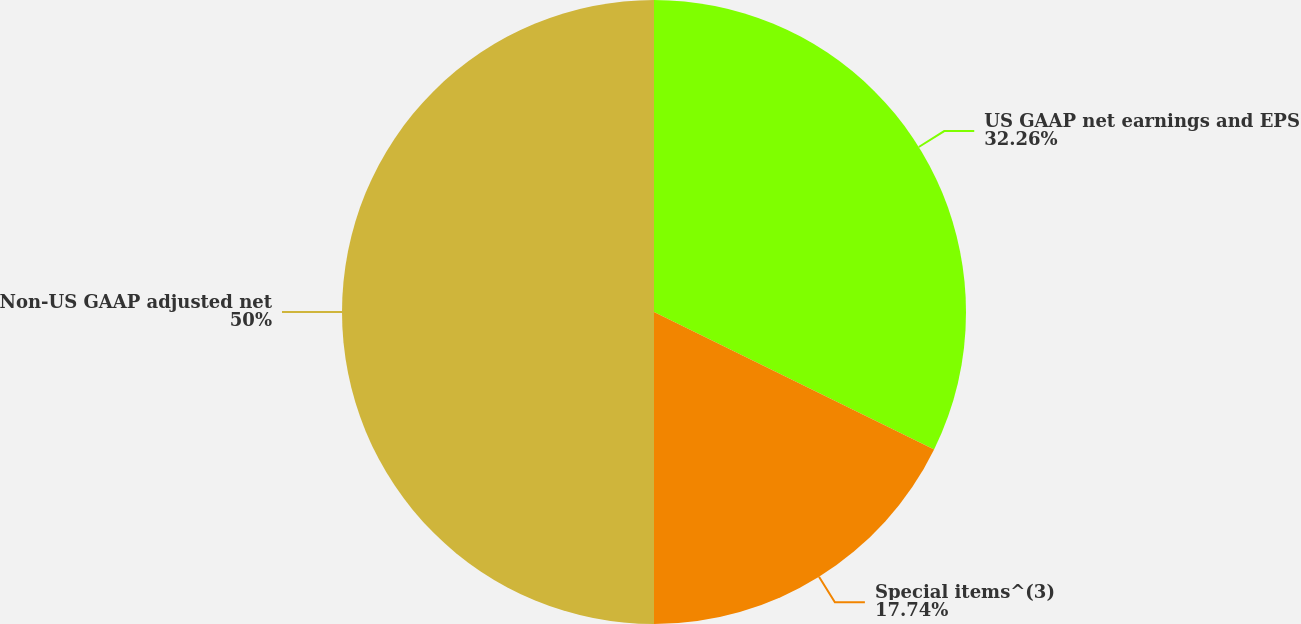Convert chart to OTSL. <chart><loc_0><loc_0><loc_500><loc_500><pie_chart><fcel>US GAAP net earnings and EPS<fcel>Special items^(3)<fcel>Non-US GAAP adjusted net<nl><fcel>32.26%<fcel>17.74%<fcel>50.0%<nl></chart> 